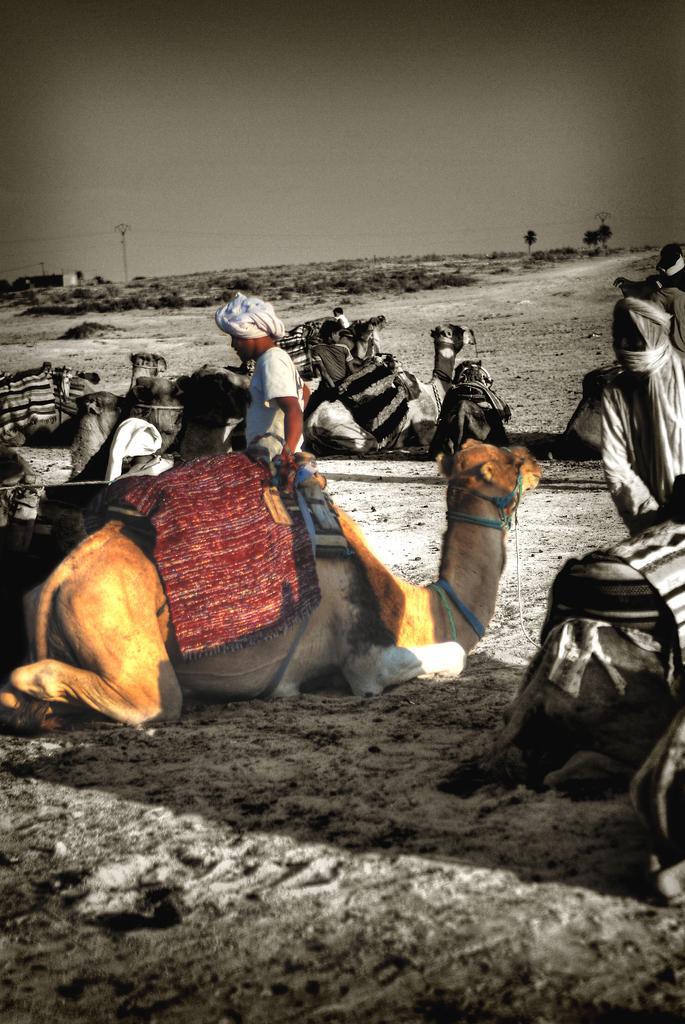Can you describe this image briefly? In this picture there are camels sitting on the sand. There is a person sitting standing behind the camel. At the back there are trees and poles and there is a building. At the top there is sky. At the bottom there is sand. 